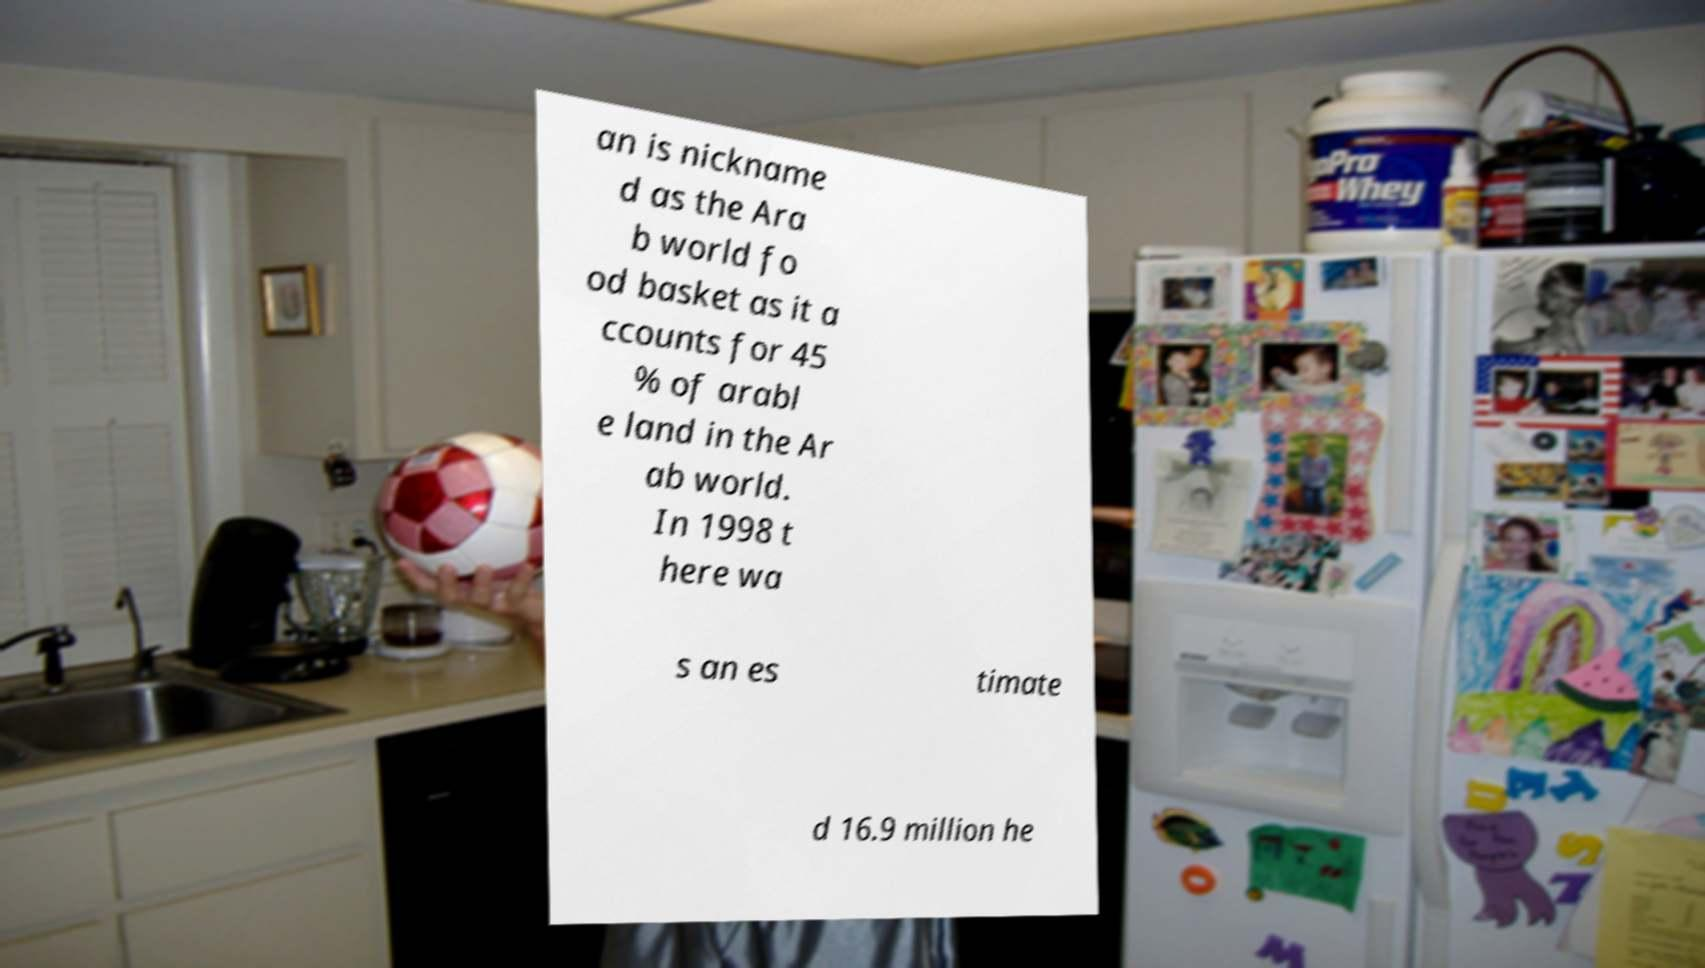Can you read and provide the text displayed in the image?This photo seems to have some interesting text. Can you extract and type it out for me? an is nickname d as the Ara b world fo od basket as it a ccounts for 45 % of arabl e land in the Ar ab world. In 1998 t here wa s an es timate d 16.9 million he 